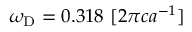<formula> <loc_0><loc_0><loc_500><loc_500>\omega _ { D } = 0 . 3 1 8 \ [ 2 \pi c a ^ { - 1 } ]</formula> 